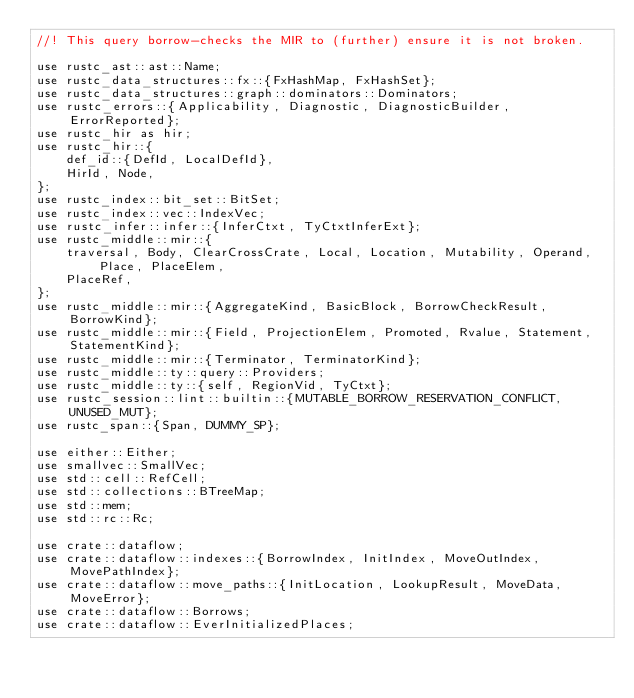<code> <loc_0><loc_0><loc_500><loc_500><_Rust_>//! This query borrow-checks the MIR to (further) ensure it is not broken.

use rustc_ast::ast::Name;
use rustc_data_structures::fx::{FxHashMap, FxHashSet};
use rustc_data_structures::graph::dominators::Dominators;
use rustc_errors::{Applicability, Diagnostic, DiagnosticBuilder, ErrorReported};
use rustc_hir as hir;
use rustc_hir::{
    def_id::{DefId, LocalDefId},
    HirId, Node,
};
use rustc_index::bit_set::BitSet;
use rustc_index::vec::IndexVec;
use rustc_infer::infer::{InferCtxt, TyCtxtInferExt};
use rustc_middle::mir::{
    traversal, Body, ClearCrossCrate, Local, Location, Mutability, Operand, Place, PlaceElem,
    PlaceRef,
};
use rustc_middle::mir::{AggregateKind, BasicBlock, BorrowCheckResult, BorrowKind};
use rustc_middle::mir::{Field, ProjectionElem, Promoted, Rvalue, Statement, StatementKind};
use rustc_middle::mir::{Terminator, TerminatorKind};
use rustc_middle::ty::query::Providers;
use rustc_middle::ty::{self, RegionVid, TyCtxt};
use rustc_session::lint::builtin::{MUTABLE_BORROW_RESERVATION_CONFLICT, UNUSED_MUT};
use rustc_span::{Span, DUMMY_SP};

use either::Either;
use smallvec::SmallVec;
use std::cell::RefCell;
use std::collections::BTreeMap;
use std::mem;
use std::rc::Rc;

use crate::dataflow;
use crate::dataflow::indexes::{BorrowIndex, InitIndex, MoveOutIndex, MovePathIndex};
use crate::dataflow::move_paths::{InitLocation, LookupResult, MoveData, MoveError};
use crate::dataflow::Borrows;
use crate::dataflow::EverInitializedPlaces;</code> 